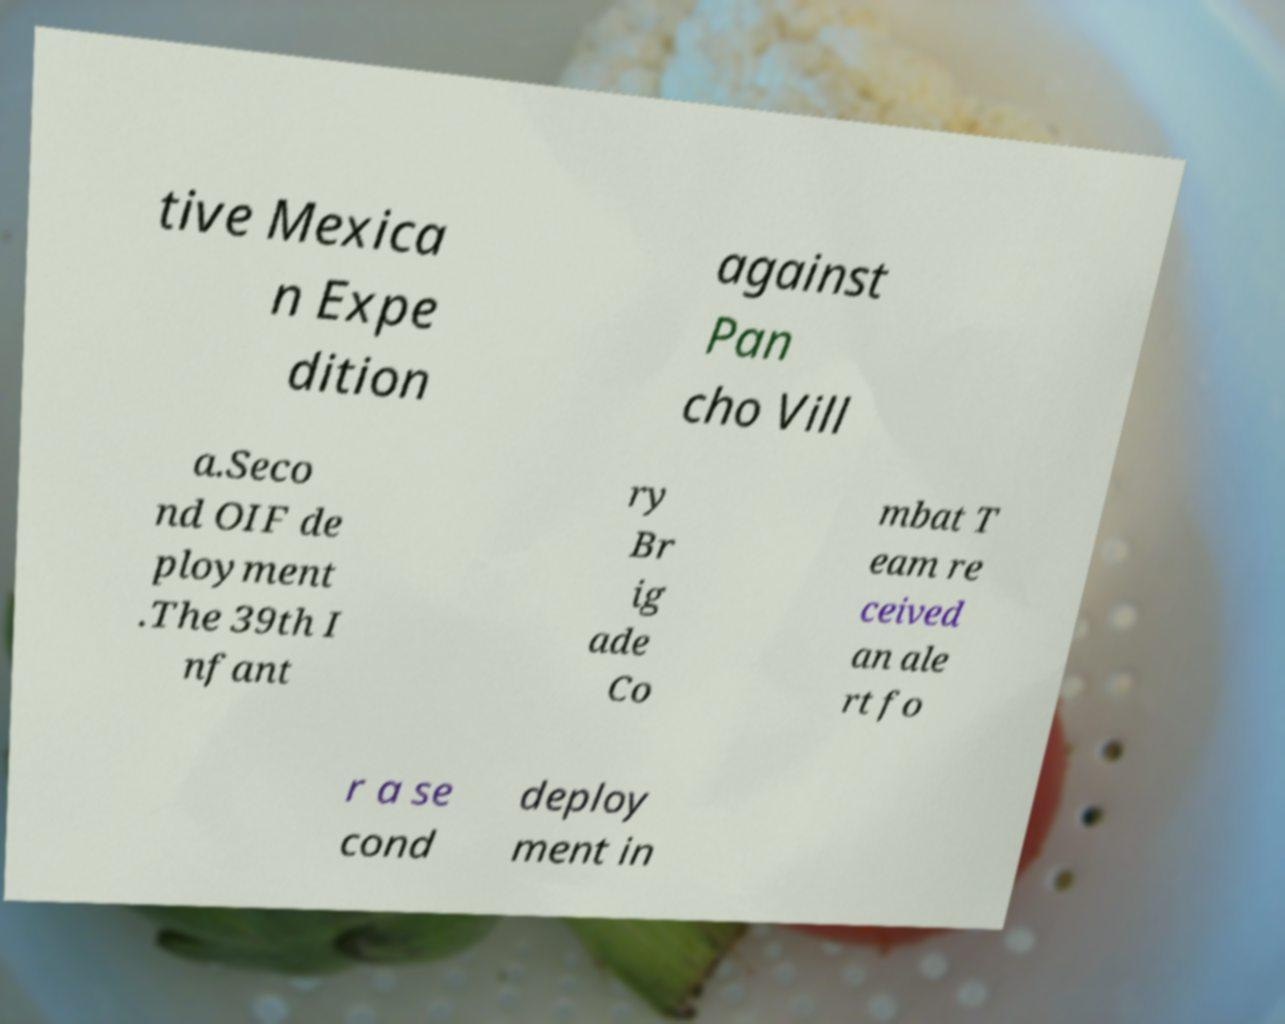Please identify and transcribe the text found in this image. tive Mexica n Expe dition against Pan cho Vill a.Seco nd OIF de ployment .The 39th I nfant ry Br ig ade Co mbat T eam re ceived an ale rt fo r a se cond deploy ment in 